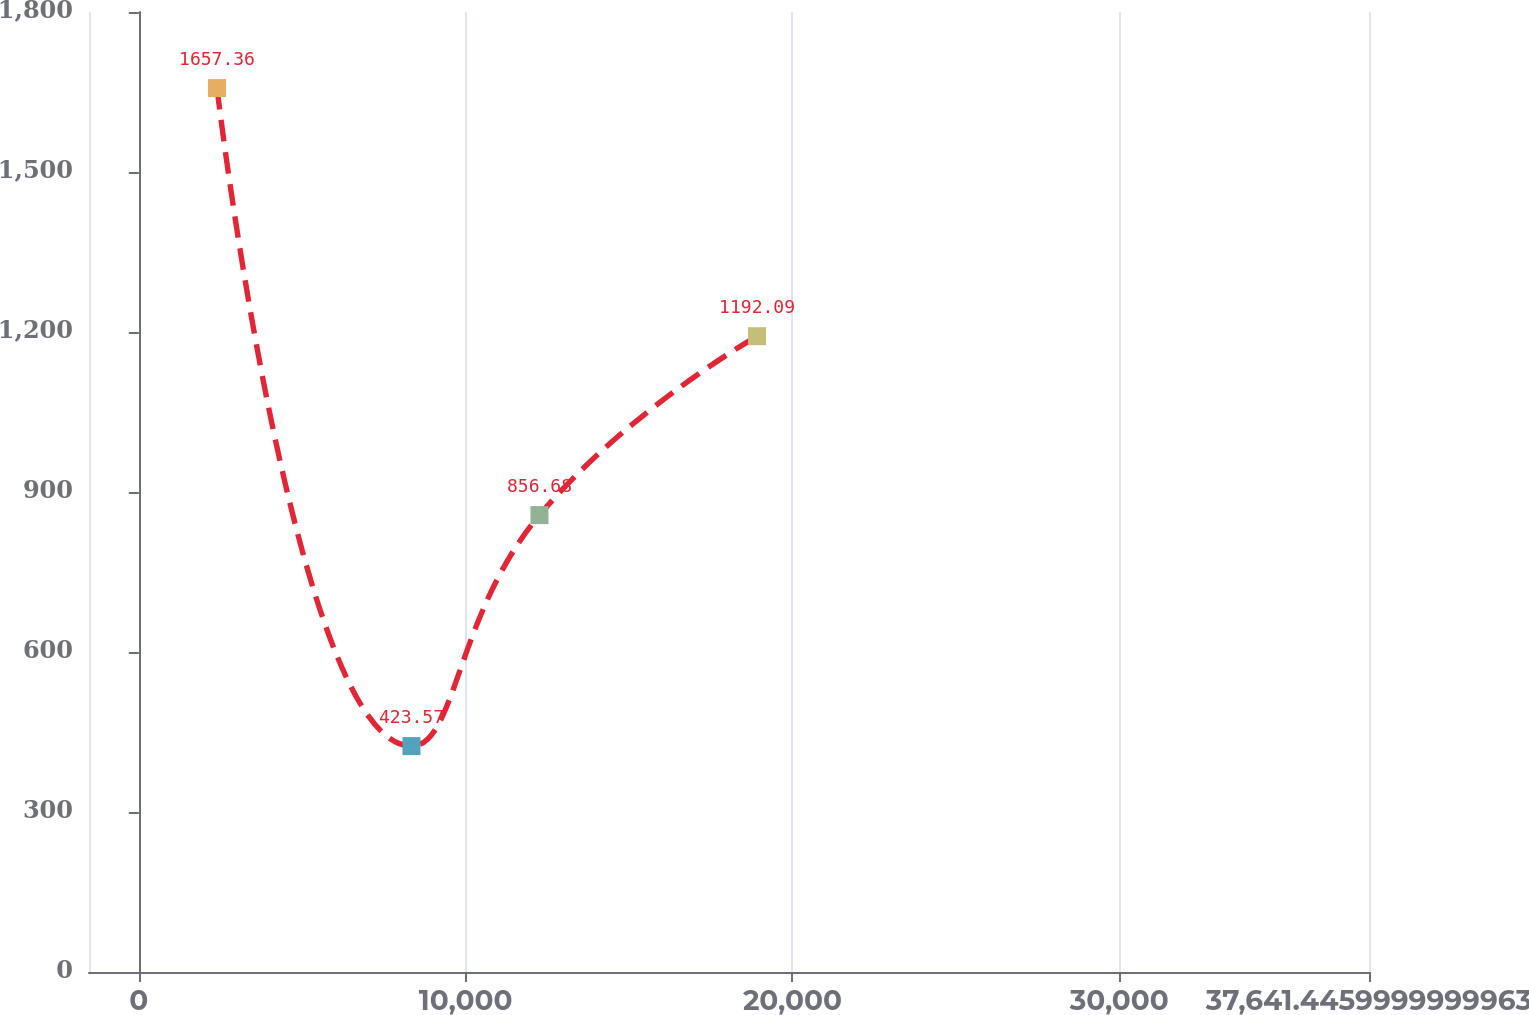<chart> <loc_0><loc_0><loc_500><loc_500><line_chart><ecel><fcel>December 31,<nl><fcel>2391.56<fcel>1657.36<nl><fcel>8341.96<fcel>423.57<nl><fcel>12258.6<fcel>856.68<nl><fcel>18916.5<fcel>1192.09<nl><fcel>41558.1<fcel>2468.98<nl></chart> 